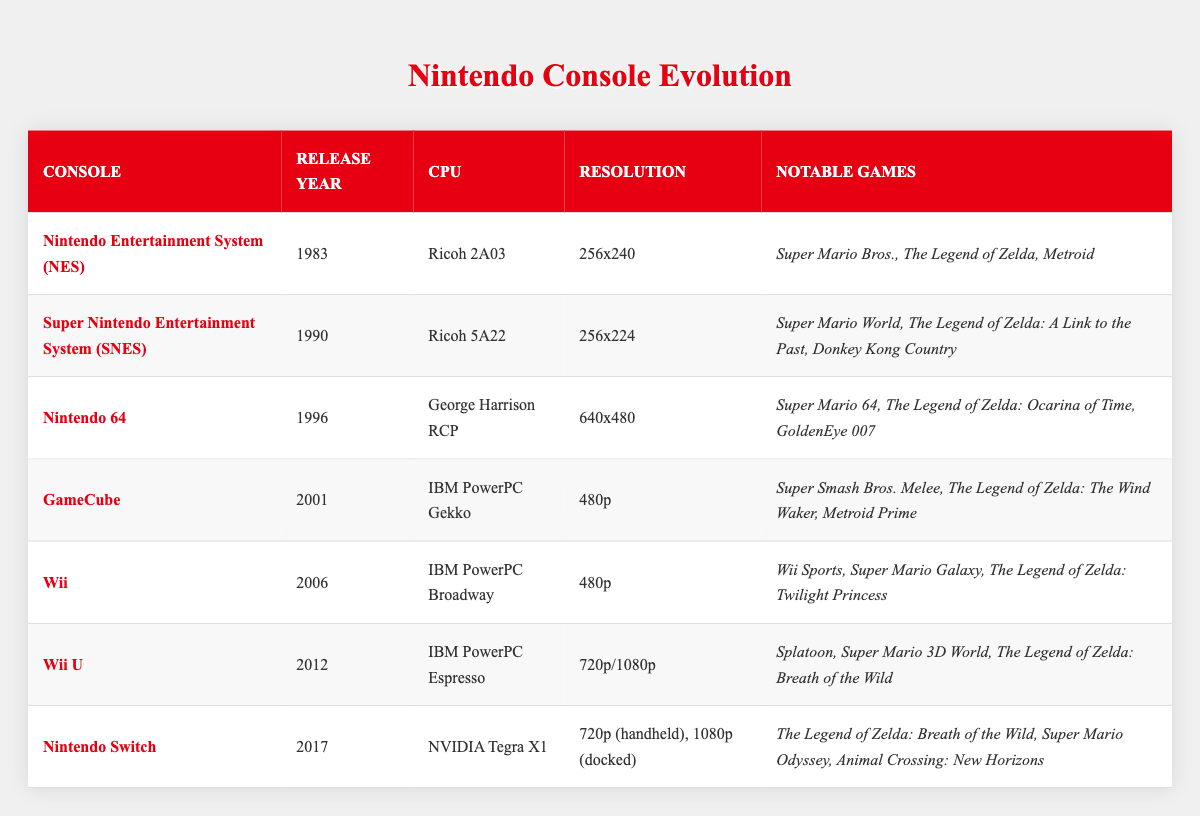What year was the Nintendo 64 released? The table shows the release year of each console listed. The Nintendo 64's row states that it was released in 1996.
Answer: 1996 Which console has a resolution of 720p? Looking at the table, the Wii U is the console that has a resolution listed as 720p/1080p.
Answer: Wii U What notable game was released for the GameCube? The table includes a list of notable games for each console. For the GameCube, one notable game is Super Smash Bros. Melee.
Answer: Super Smash Bros. Melee How many consoles were released before the Wii? By examining the release years listed, the NES, SNES, Nintendo 64, GameCube, and Wii U were released before the Wii (which was released in 2006). This totals to 5 consoles.
Answer: 5 Was the CPU used in the Wii U also used in the Wii? The table shows that both the Wii and Wii U used IBM PowerPC CPUs, but with different names (Broadway for Wii and Espresso for Wii U). Therefore, the fact that both use IBM PowerPC processors is true.
Answer: Yes What is the difference in resolution between the Nintendo Switch and the NES? The Nintendo Switch has a resolution of 720p (handheld) or 1080p (docked), while the NES has a resolution of 256x240. To compare resolutions, we consider that 720p is higher than 240 pixels (in height), and 1080p is far higher than 240 pixels. Therefore, the Nintendo Switch has a significantly greater resolution.
Answer: Significant difference Which console had the highest resolution? The table reveals that the Nintendo Switch has the highest resolution, with 720p (handheld) and 1080p (docked), compared to the others listed.
Answer: Nintendo Switch List the notable games for the Wii. The notable games listed for the Wii in the table include Wii Sports, Super Mario Galaxy, and The Legend of Zelda: Twilight Princess.
Answer: Wii Sports, Super Mario Galaxy, The Legend of Zelda: Twilight Princess Calculate the average release year of the first three consoles. The first three consoles are NES (1983), SNES (1990), and Nintendo 64 (1996). The average is calculated as (1983 + 1990 + 1996) / 3 = 1989.67, which rounds to 1990.
Answer: 1990 What is the CPU of the Nintendo Switch? Referring to the table, the CPU listed for the Nintendo Switch is NVIDIA Tegra X1.
Answer: NVIDIA Tegra X1 Which notable game appears on both the Wii U and the Nintendo Switch? The table shows that The Legend of Zelda: Breath of the Wild is a notable game for both the Wii U and the Nintendo Switch.
Answer: The Legend of Zelda: Breath of the Wild 